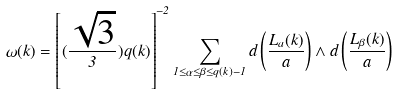Convert formula to latex. <formula><loc_0><loc_0><loc_500><loc_500>\omega ( k ) = \left [ ( \frac { \sqrt { 3 } } { 3 } ) q ( k ) \right ] ^ { - 2 } \sum _ { 1 \leq \alpha \leq \beta \leq q ( k ) - 1 } d \left ( \frac { L _ { a } ( k ) } { a } \right ) \wedge d \left ( \frac { L _ { \beta } ( k ) } { a } \right )</formula> 